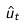<formula> <loc_0><loc_0><loc_500><loc_500>\hat { u } _ { t }</formula> 